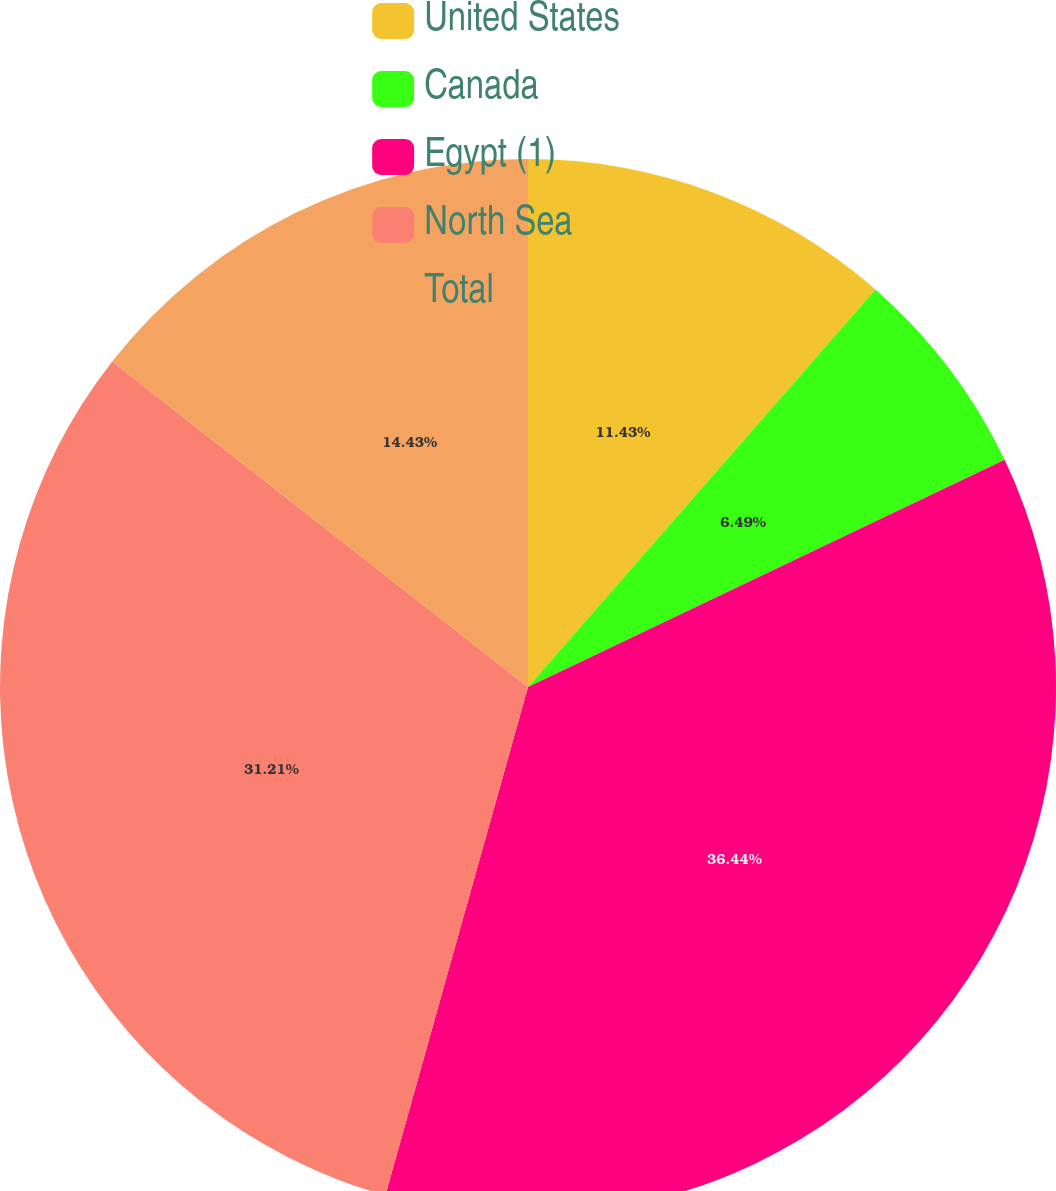Convert chart. <chart><loc_0><loc_0><loc_500><loc_500><pie_chart><fcel>United States<fcel>Canada<fcel>Egypt (1)<fcel>North Sea<fcel>Total<nl><fcel>11.43%<fcel>6.49%<fcel>36.43%<fcel>31.21%<fcel>14.43%<nl></chart> 